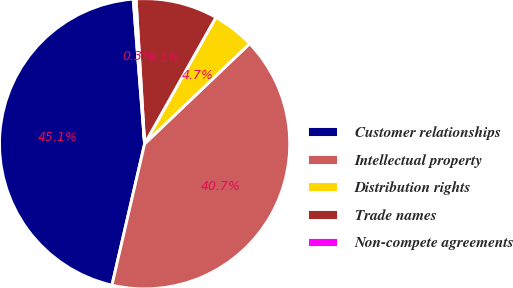Convert chart. <chart><loc_0><loc_0><loc_500><loc_500><pie_chart><fcel>Customer relationships<fcel>Intellectual property<fcel>Distribution rights<fcel>Trade names<fcel>Non-compete agreements<nl><fcel>45.13%<fcel>40.73%<fcel>4.71%<fcel>9.11%<fcel>0.31%<nl></chart> 